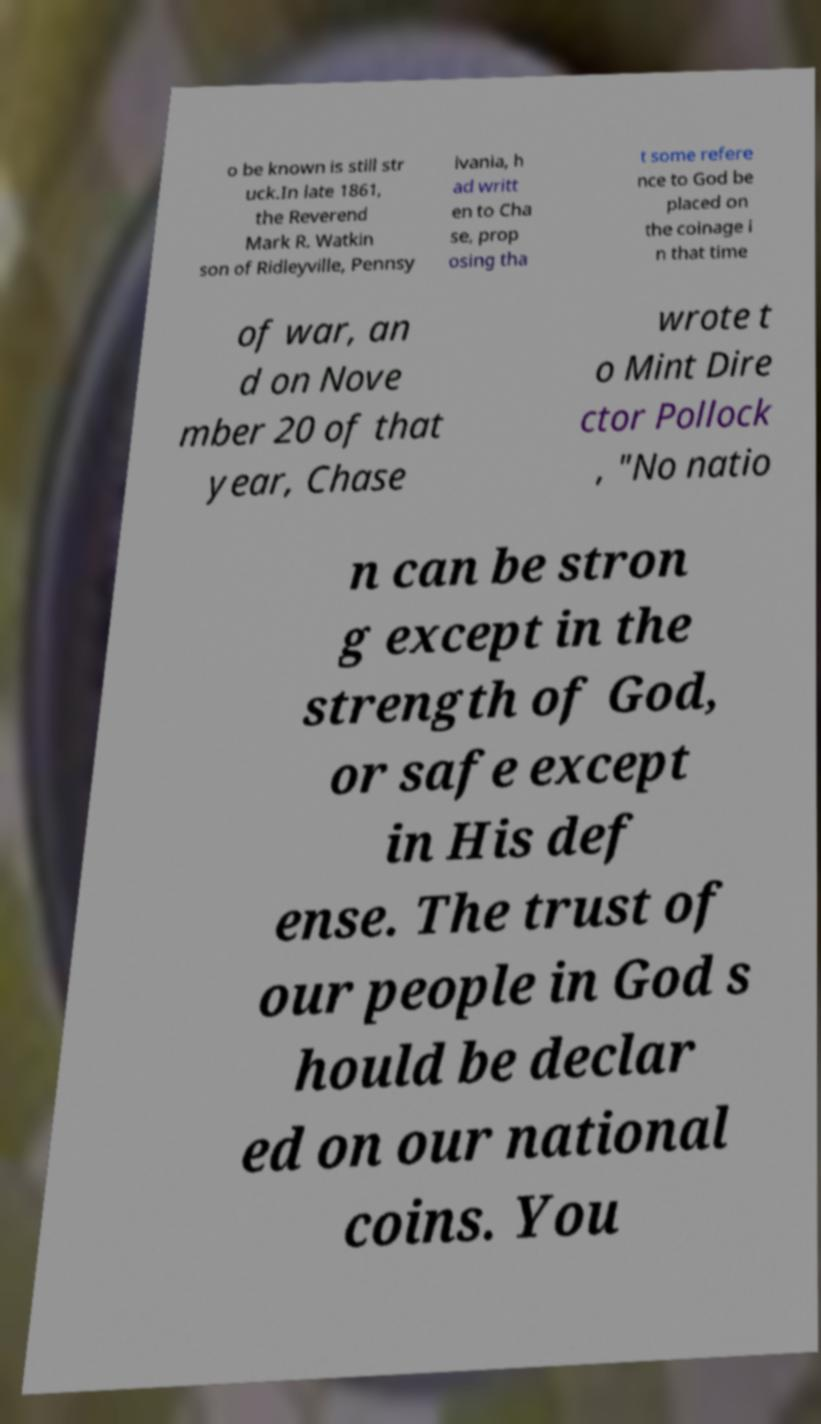Can you read and provide the text displayed in the image?This photo seems to have some interesting text. Can you extract and type it out for me? o be known is still str uck.In late 1861, the Reverend Mark R. Watkin son of Ridleyville, Pennsy lvania, h ad writt en to Cha se, prop osing tha t some refere nce to God be placed on the coinage i n that time of war, an d on Nove mber 20 of that year, Chase wrote t o Mint Dire ctor Pollock , "No natio n can be stron g except in the strength of God, or safe except in His def ense. The trust of our people in God s hould be declar ed on our national coins. You 